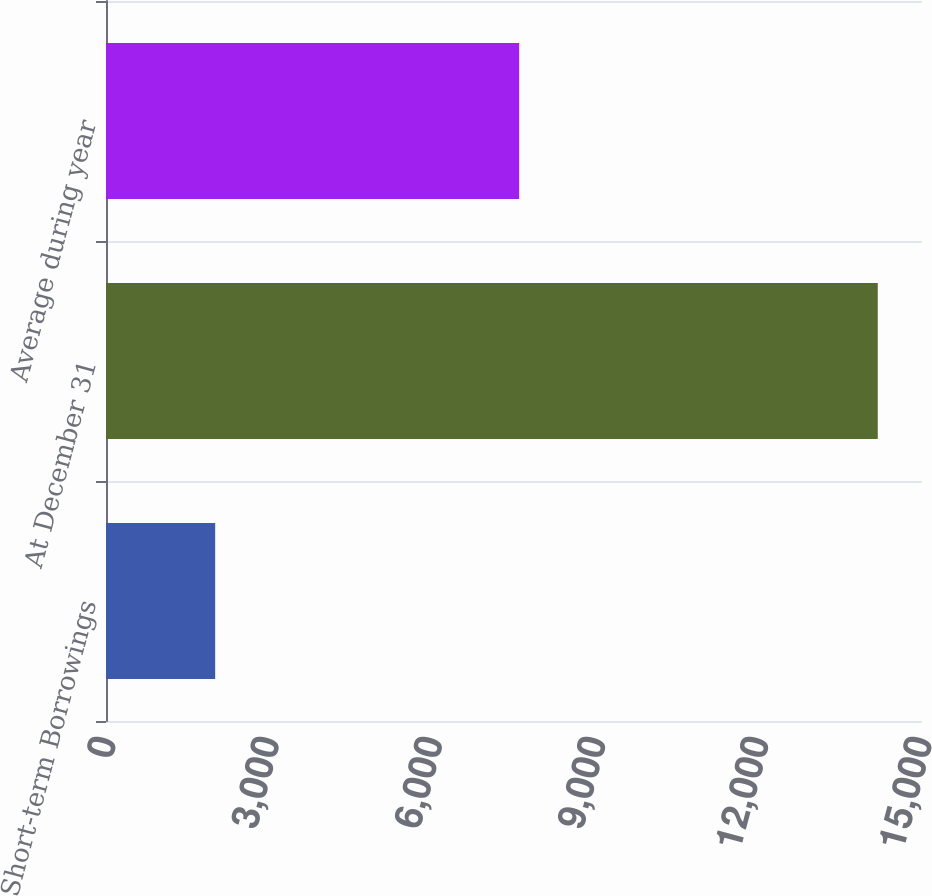Convert chart. <chart><loc_0><loc_0><loc_500><loc_500><bar_chart><fcel>Short-term Borrowings<fcel>At December 31<fcel>Average during year<nl><fcel>2007<fcel>14187<fcel>7595<nl></chart> 